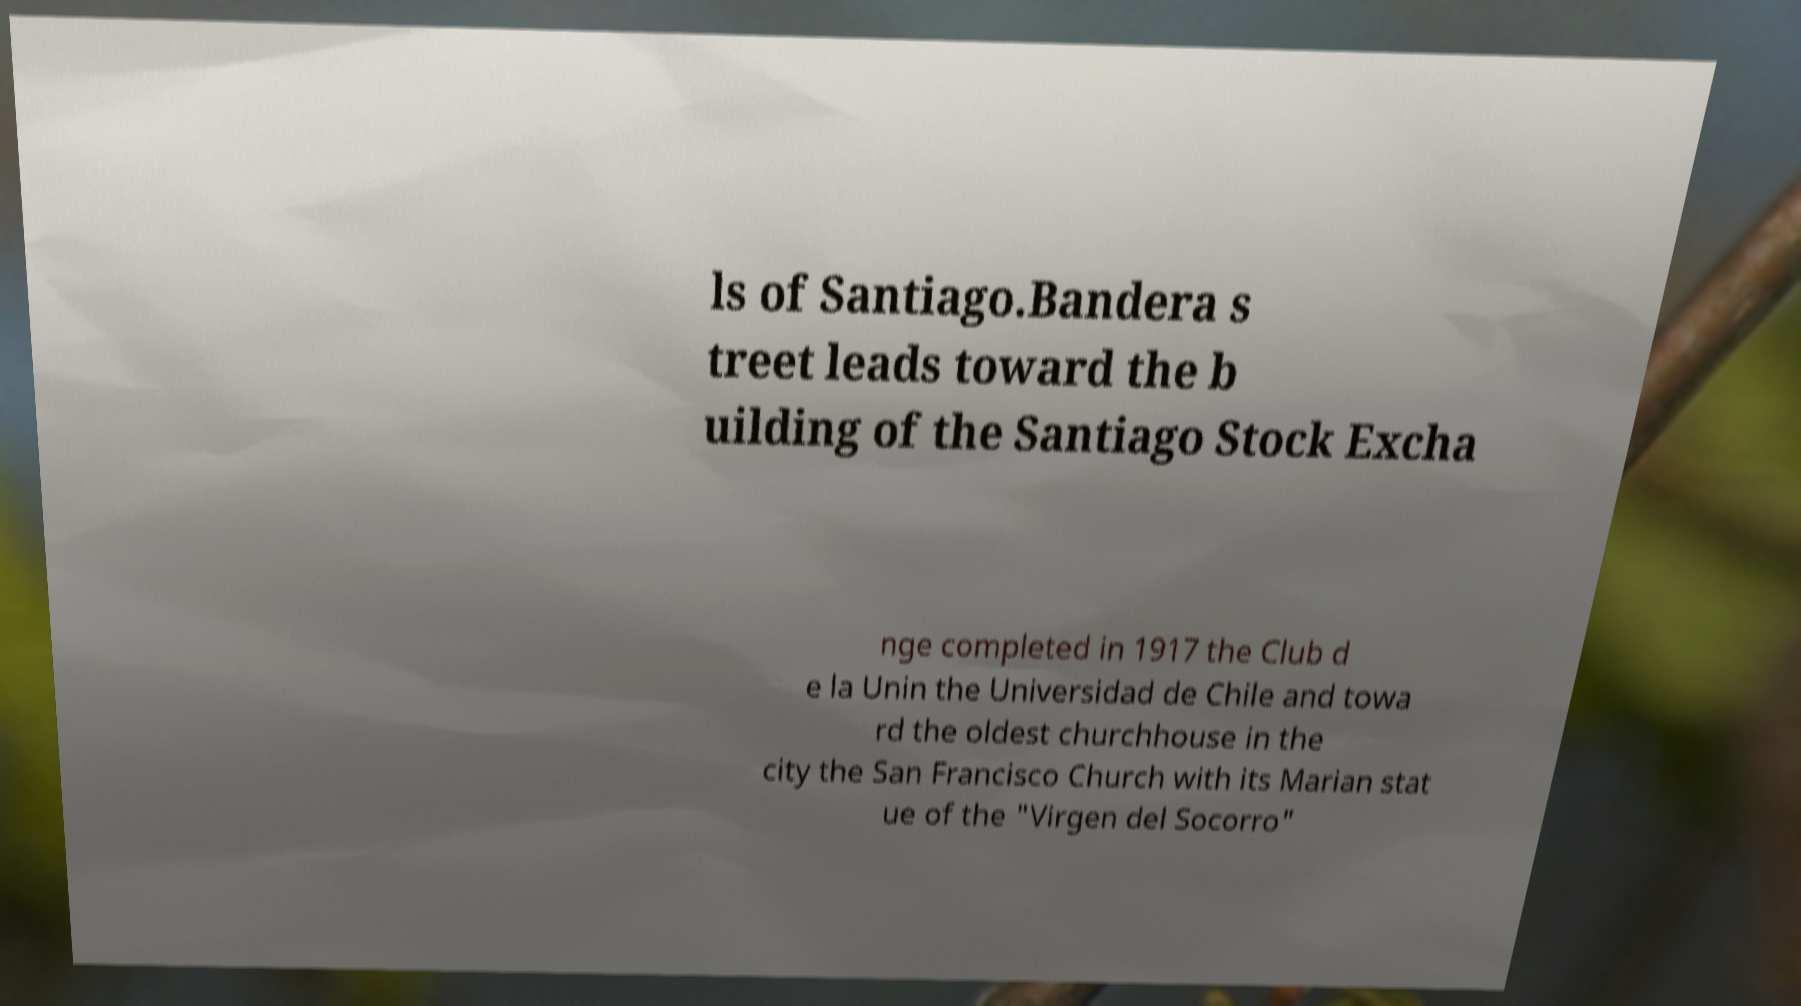Please identify and transcribe the text found in this image. ls of Santiago.Bandera s treet leads toward the b uilding of the Santiago Stock Excha nge completed in 1917 the Club d e la Unin the Universidad de Chile and towa rd the oldest churchhouse in the city the San Francisco Church with its Marian stat ue of the "Virgen del Socorro" 